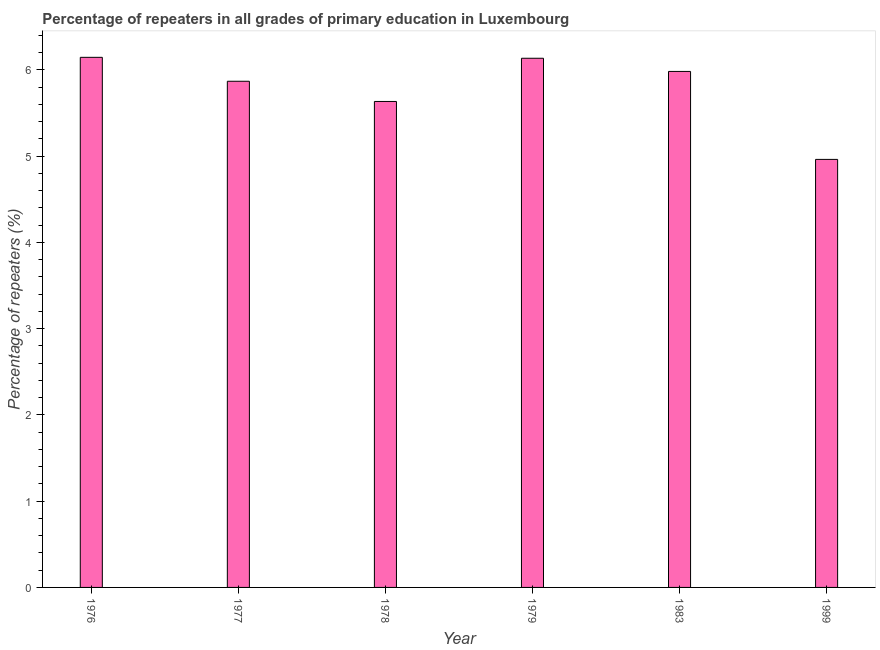Does the graph contain any zero values?
Give a very brief answer. No. What is the title of the graph?
Provide a short and direct response. Percentage of repeaters in all grades of primary education in Luxembourg. What is the label or title of the X-axis?
Provide a short and direct response. Year. What is the label or title of the Y-axis?
Keep it short and to the point. Percentage of repeaters (%). What is the percentage of repeaters in primary education in 1983?
Your response must be concise. 5.98. Across all years, what is the maximum percentage of repeaters in primary education?
Your answer should be very brief. 6.15. Across all years, what is the minimum percentage of repeaters in primary education?
Provide a short and direct response. 4.96. In which year was the percentage of repeaters in primary education maximum?
Your answer should be compact. 1976. In which year was the percentage of repeaters in primary education minimum?
Keep it short and to the point. 1999. What is the sum of the percentage of repeaters in primary education?
Provide a succinct answer. 34.73. What is the difference between the percentage of repeaters in primary education in 1979 and 1983?
Offer a very short reply. 0.15. What is the average percentage of repeaters in primary education per year?
Make the answer very short. 5.79. What is the median percentage of repeaters in primary education?
Offer a terse response. 5.93. In how many years, is the percentage of repeaters in primary education greater than 4.6 %?
Provide a short and direct response. 6. Is the percentage of repeaters in primary education in 1976 less than that in 1979?
Provide a succinct answer. No. What is the difference between the highest and the second highest percentage of repeaters in primary education?
Give a very brief answer. 0.01. Is the sum of the percentage of repeaters in primary education in 1978 and 1999 greater than the maximum percentage of repeaters in primary education across all years?
Your answer should be compact. Yes. What is the difference between the highest and the lowest percentage of repeaters in primary education?
Ensure brevity in your answer.  1.18. In how many years, is the percentage of repeaters in primary education greater than the average percentage of repeaters in primary education taken over all years?
Provide a short and direct response. 4. How many bars are there?
Your answer should be very brief. 6. Are all the bars in the graph horizontal?
Your response must be concise. No. Are the values on the major ticks of Y-axis written in scientific E-notation?
Your answer should be very brief. No. What is the Percentage of repeaters (%) of 1976?
Provide a short and direct response. 6.15. What is the Percentage of repeaters (%) in 1977?
Offer a terse response. 5.87. What is the Percentage of repeaters (%) in 1978?
Give a very brief answer. 5.63. What is the Percentage of repeaters (%) of 1979?
Give a very brief answer. 6.14. What is the Percentage of repeaters (%) of 1983?
Ensure brevity in your answer.  5.98. What is the Percentage of repeaters (%) in 1999?
Provide a succinct answer. 4.96. What is the difference between the Percentage of repeaters (%) in 1976 and 1977?
Offer a very short reply. 0.28. What is the difference between the Percentage of repeaters (%) in 1976 and 1978?
Provide a succinct answer. 0.51. What is the difference between the Percentage of repeaters (%) in 1976 and 1979?
Offer a terse response. 0.01. What is the difference between the Percentage of repeaters (%) in 1976 and 1983?
Give a very brief answer. 0.16. What is the difference between the Percentage of repeaters (%) in 1976 and 1999?
Your answer should be very brief. 1.18. What is the difference between the Percentage of repeaters (%) in 1977 and 1978?
Provide a succinct answer. 0.23. What is the difference between the Percentage of repeaters (%) in 1977 and 1979?
Provide a succinct answer. -0.27. What is the difference between the Percentage of repeaters (%) in 1977 and 1983?
Offer a very short reply. -0.11. What is the difference between the Percentage of repeaters (%) in 1977 and 1999?
Keep it short and to the point. 0.91. What is the difference between the Percentage of repeaters (%) in 1978 and 1979?
Keep it short and to the point. -0.5. What is the difference between the Percentage of repeaters (%) in 1978 and 1983?
Provide a short and direct response. -0.35. What is the difference between the Percentage of repeaters (%) in 1978 and 1999?
Provide a succinct answer. 0.67. What is the difference between the Percentage of repeaters (%) in 1979 and 1983?
Ensure brevity in your answer.  0.15. What is the difference between the Percentage of repeaters (%) in 1979 and 1999?
Your answer should be compact. 1.17. What is the difference between the Percentage of repeaters (%) in 1983 and 1999?
Make the answer very short. 1.02. What is the ratio of the Percentage of repeaters (%) in 1976 to that in 1977?
Your answer should be very brief. 1.05. What is the ratio of the Percentage of repeaters (%) in 1976 to that in 1978?
Your response must be concise. 1.09. What is the ratio of the Percentage of repeaters (%) in 1976 to that in 1999?
Provide a succinct answer. 1.24. What is the ratio of the Percentage of repeaters (%) in 1977 to that in 1978?
Your answer should be very brief. 1.04. What is the ratio of the Percentage of repeaters (%) in 1977 to that in 1983?
Provide a short and direct response. 0.98. What is the ratio of the Percentage of repeaters (%) in 1977 to that in 1999?
Your response must be concise. 1.18. What is the ratio of the Percentage of repeaters (%) in 1978 to that in 1979?
Provide a succinct answer. 0.92. What is the ratio of the Percentage of repeaters (%) in 1978 to that in 1983?
Provide a succinct answer. 0.94. What is the ratio of the Percentage of repeaters (%) in 1978 to that in 1999?
Your answer should be very brief. 1.14. What is the ratio of the Percentage of repeaters (%) in 1979 to that in 1983?
Your response must be concise. 1.03. What is the ratio of the Percentage of repeaters (%) in 1979 to that in 1999?
Offer a terse response. 1.24. What is the ratio of the Percentage of repeaters (%) in 1983 to that in 1999?
Ensure brevity in your answer.  1.21. 